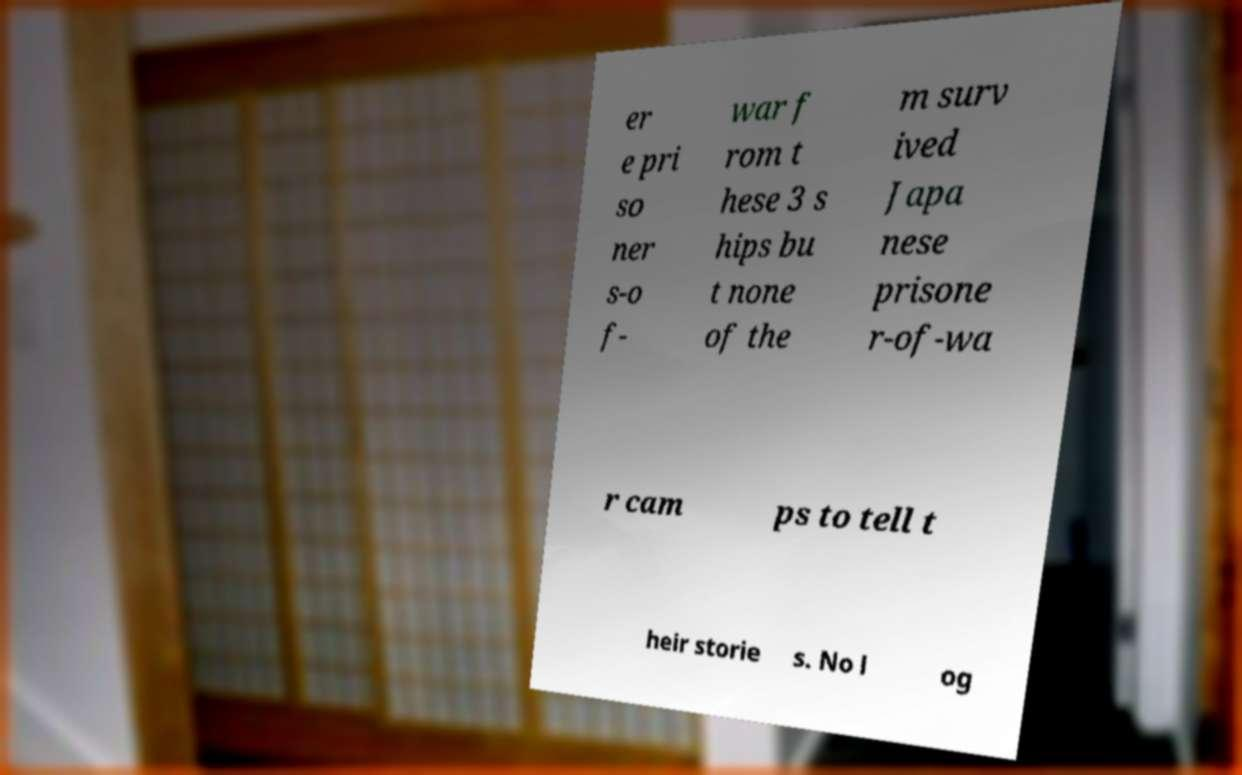I need the written content from this picture converted into text. Can you do that? er e pri so ner s-o f- war f rom t hese 3 s hips bu t none of the m surv ived Japa nese prisone r-of-wa r cam ps to tell t heir storie s. No l og 